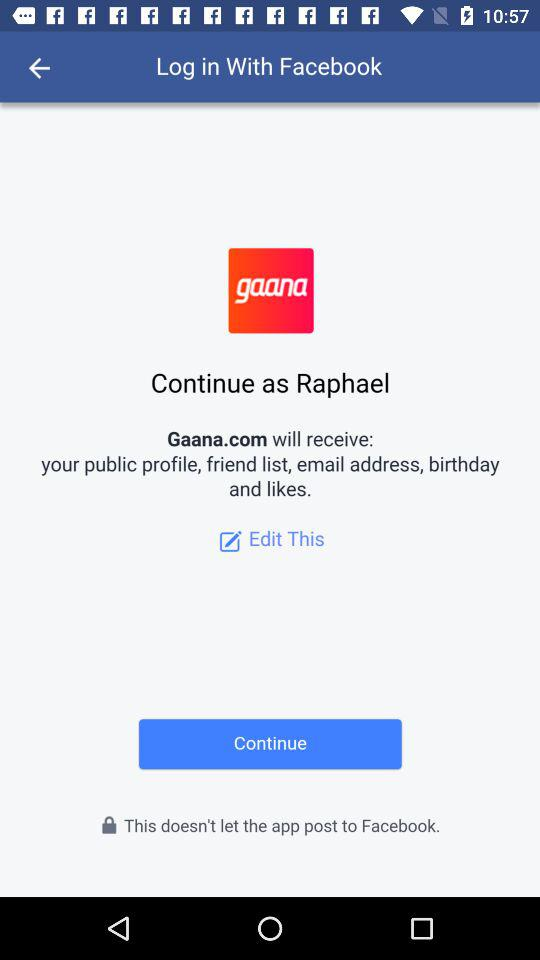Through what application can we log in? We can log in through "Facebook". 